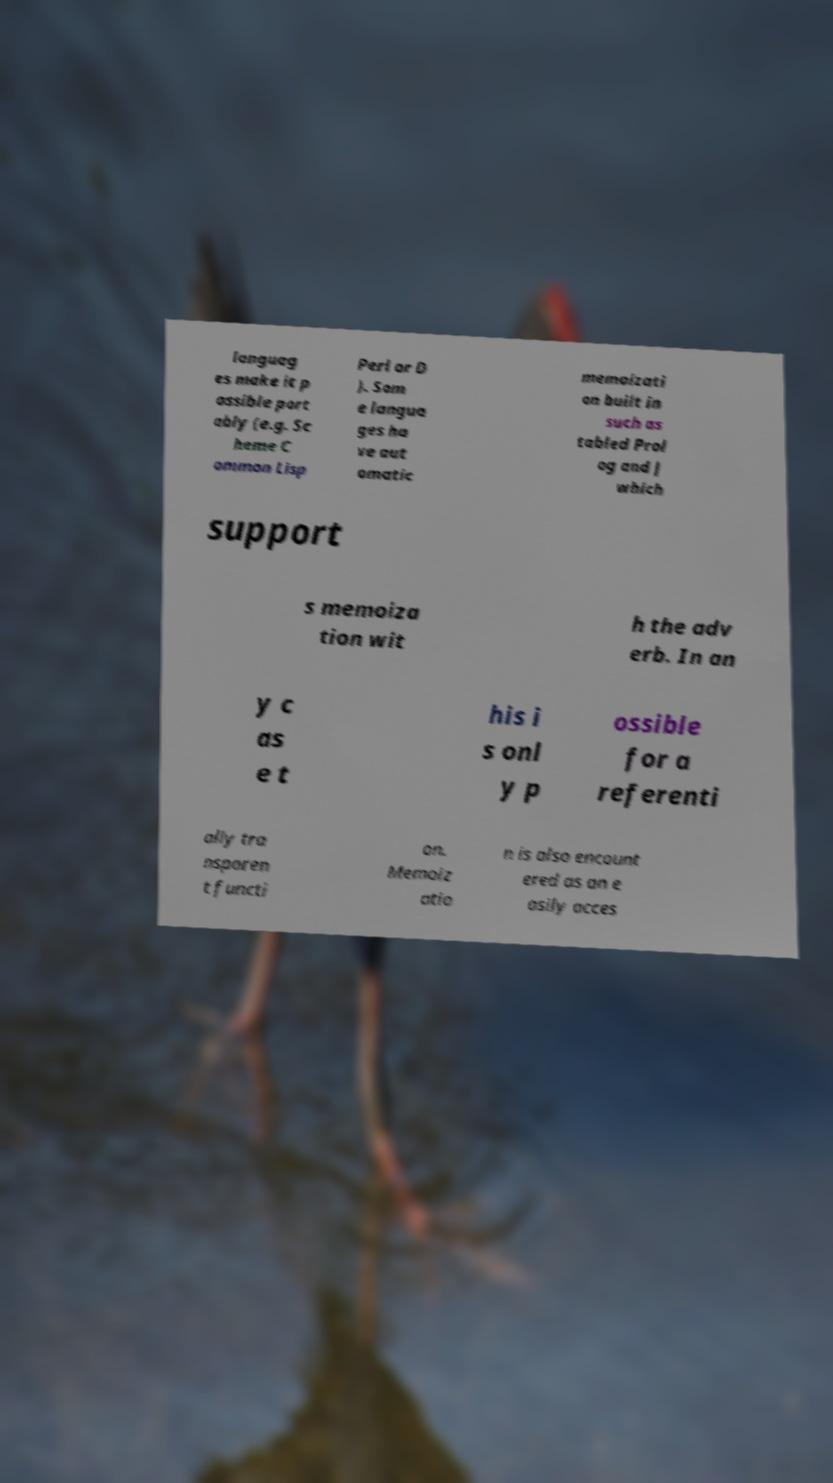There's text embedded in this image that I need extracted. Can you transcribe it verbatim? languag es make it p ossible port ably (e.g. Sc heme C ommon Lisp Perl or D ). Som e langua ges ha ve aut omatic memoizati on built in such as tabled Prol og and J which support s memoiza tion wit h the adv erb. In an y c as e t his i s onl y p ossible for a referenti ally tra nsparen t functi on. Memoiz atio n is also encount ered as an e asily acces 